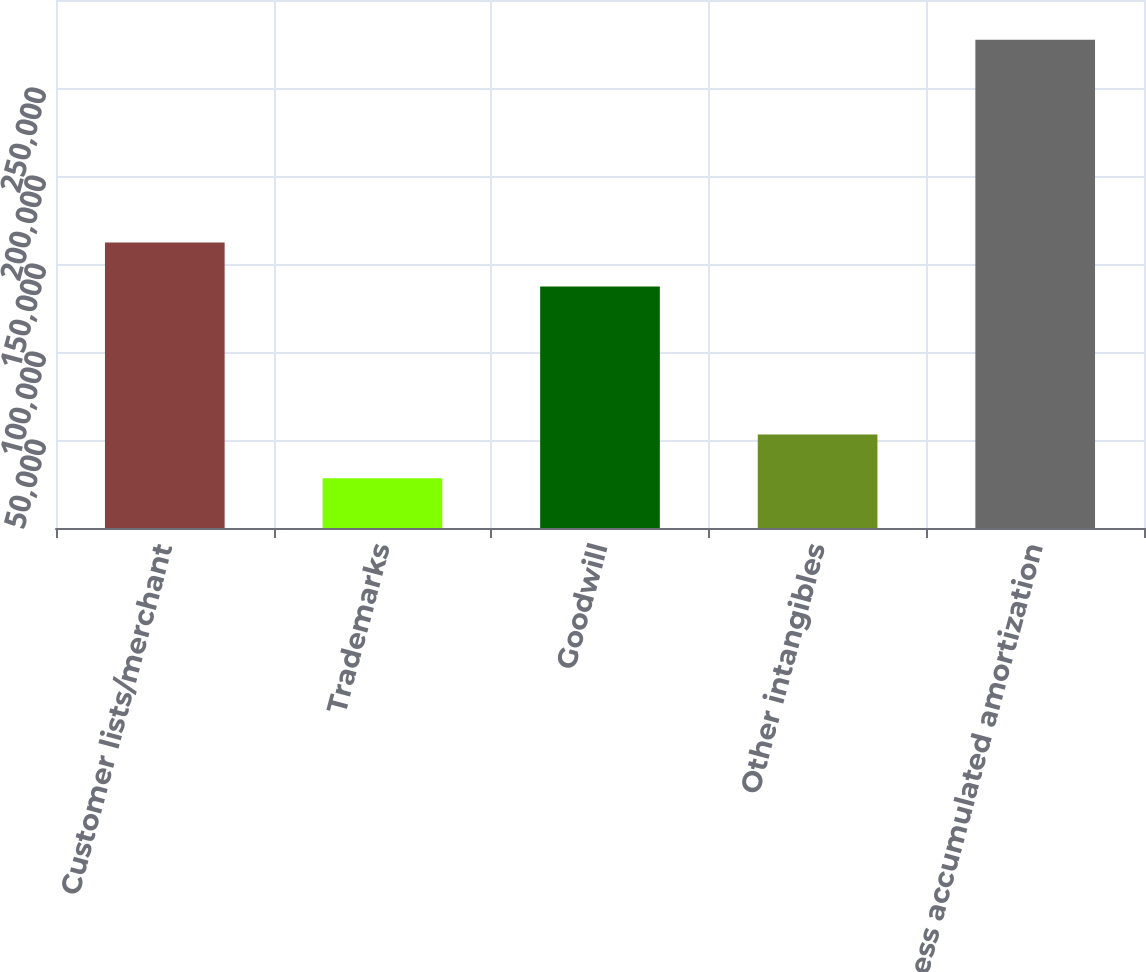Convert chart to OTSL. <chart><loc_0><loc_0><loc_500><loc_500><bar_chart><fcel>Customer lists/merchant<fcel>Trademarks<fcel>Goodwill<fcel>Other intangibles<fcel>Less accumulated amortization<nl><fcel>162191<fcel>28273<fcel>137281<fcel>53183.2<fcel>277375<nl></chart> 